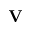Convert formula to latex. <formula><loc_0><loc_0><loc_500><loc_500>{ V }</formula> 